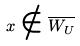Convert formula to latex. <formula><loc_0><loc_0><loc_500><loc_500>x \notin \overline { W _ { U } }</formula> 